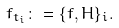<formula> <loc_0><loc_0><loc_500><loc_500>f _ { t _ { i } } \colon = \{ f , H \} _ { i } .</formula> 